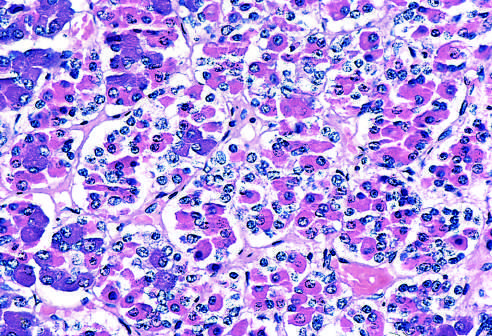re normal marrow cells basophilic (blue), eosinophilic (red), or nonstaining in routine sections stained with hematoxylin and eosin, which allows the various cell types to be identified?
Answer the question using a single word or phrase. No 